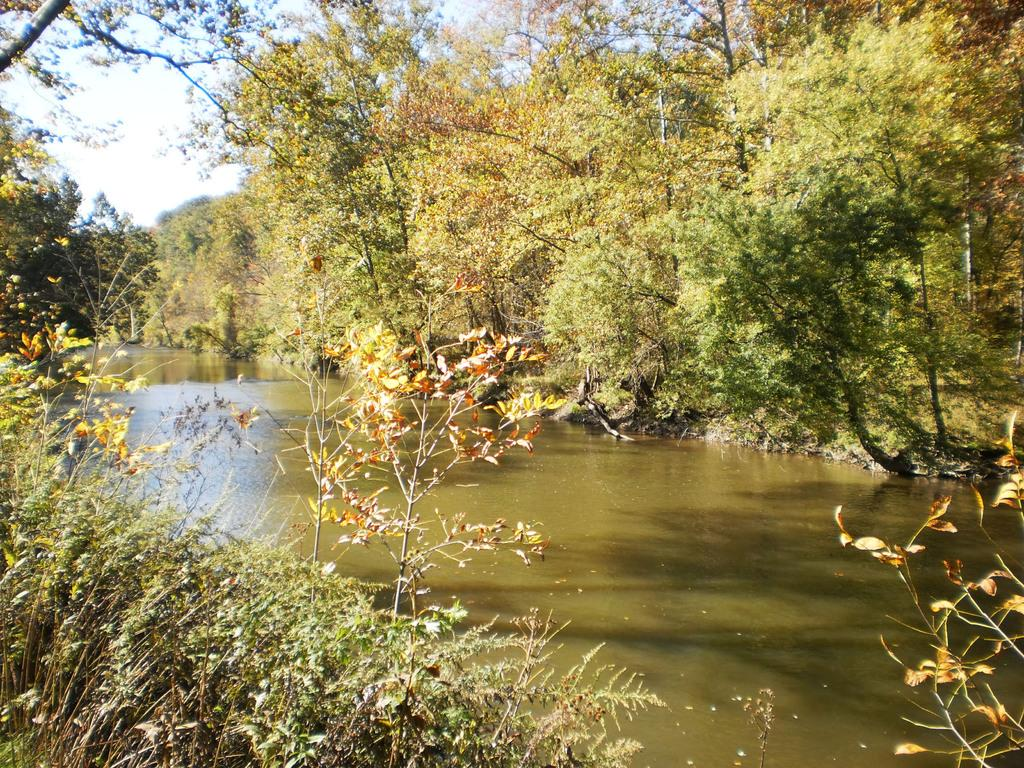What is one of the natural elements visible in the image? Water is visible in the image. What type of vegetation can be seen in the image? There are plants and trees in the image. What part of the natural environment is visible in the image? The sky is visible in the image. What type of metal can be seen in the image? There is no metal present in the image; it features natural elements such as water, plants, trees, and the sky. 